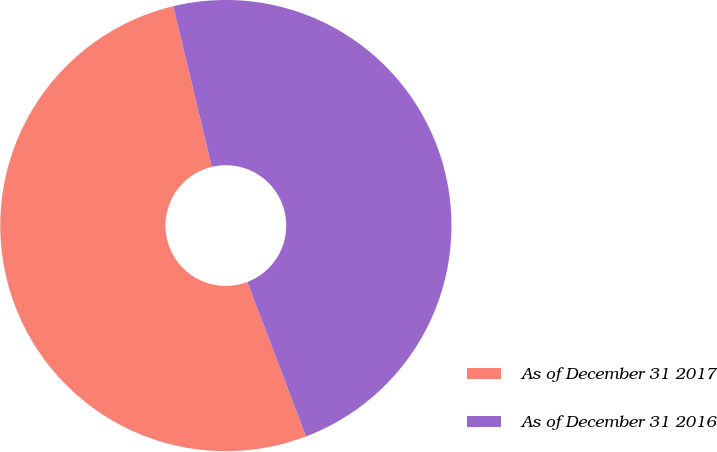<chart> <loc_0><loc_0><loc_500><loc_500><pie_chart><fcel>As of December 31 2017<fcel>As of December 31 2016<nl><fcel>52.04%<fcel>47.96%<nl></chart> 